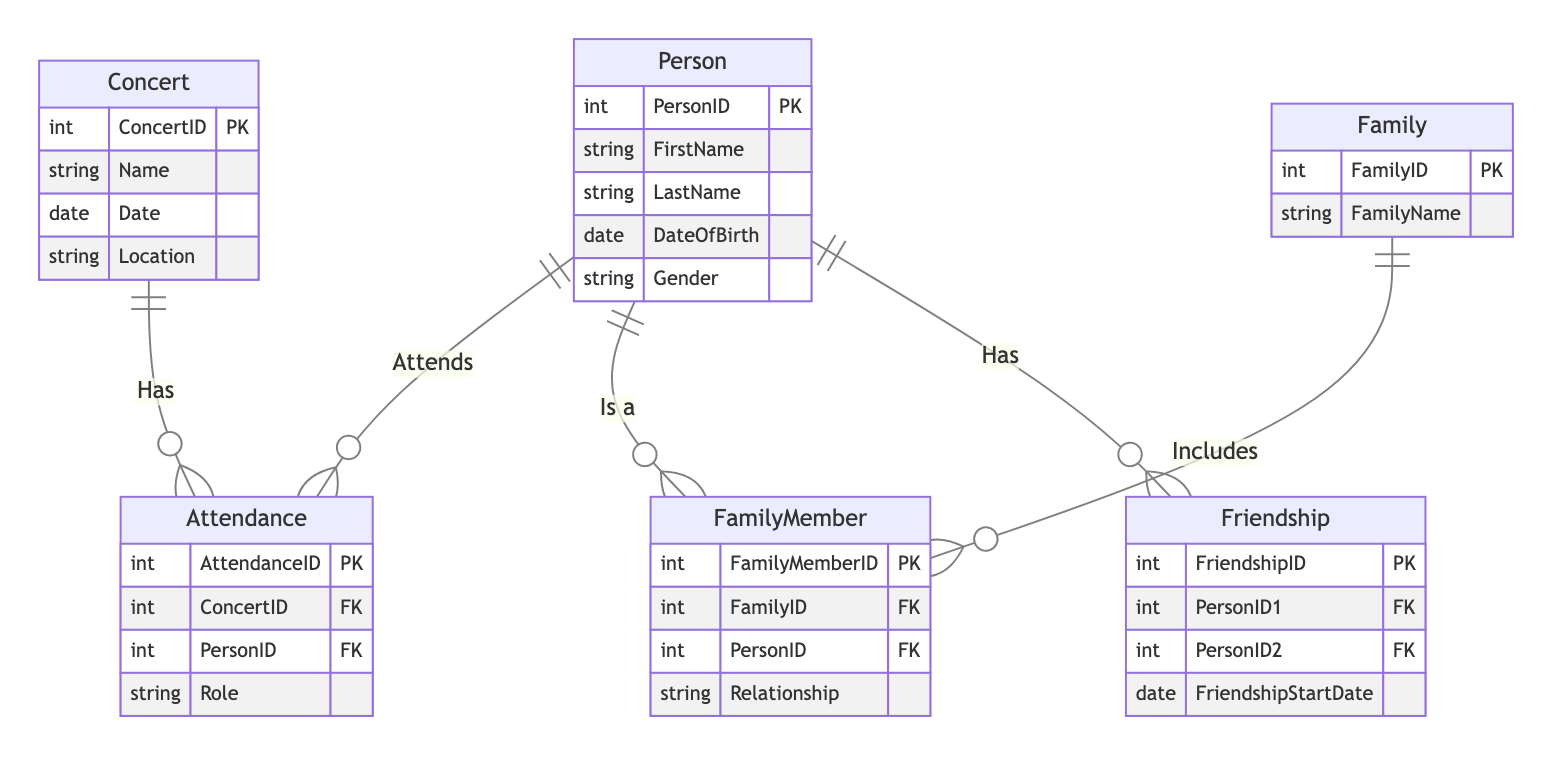What is the primary key of the Person entity? The primary key of the Person entity is "PersonID," which uniquely identifies each person in the diagram.
Answer: PersonID How many relationships are there between the Person and Concert entities? There is one relationship called "Attends" that connects the Person and Concert entities, indicating the attendance of persons at concerts.
Answer: 1 What is the name of the relationship that connects a Person to their Family? The relationship that connects a Person to their Family is called "BelongsTo." This indicates which family a person is part of.
Answer: BelongsTo How many attributes does the Concert entity have? The Concert entity has four attributes: ConcertID, Name, Date, and Location, which describe various details about a concert.
Answer: 4 Which two entities are part of the Friendship relationship? The Friendship relationship connects two instances of the Person entity; it shows friendships between two people.
Answer: Person, Person How is the FamilyMember entity related to the Family entity? The FamilyMember entity is related to the Family entity through the relationship "Includes." It indicates that a family consists of multiple family members.
Answer: Includes What role does the Attendance entity play in the relationship between Person and Concert? The Attendance entity acts as a junction that details who attends which concert by connecting the Person and Concert entities.
Answer: Junction Which attribute in the FamilyMember entity specifies the type of relationship to the Family? The attribute "Relationship" in the FamilyMember entity describes the nature or type of relationship that a family member has within the family.
Answer: Relationship What is indicated by the "HasFriend" relationship in the diagram? The "HasFriend" relationship indicates that there is a friendly connection between two different persons, showing social interactions.
Answer: Social connection 